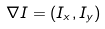<formula> <loc_0><loc_0><loc_500><loc_500>\nabla I = ( I _ { x } , I _ { y } )</formula> 